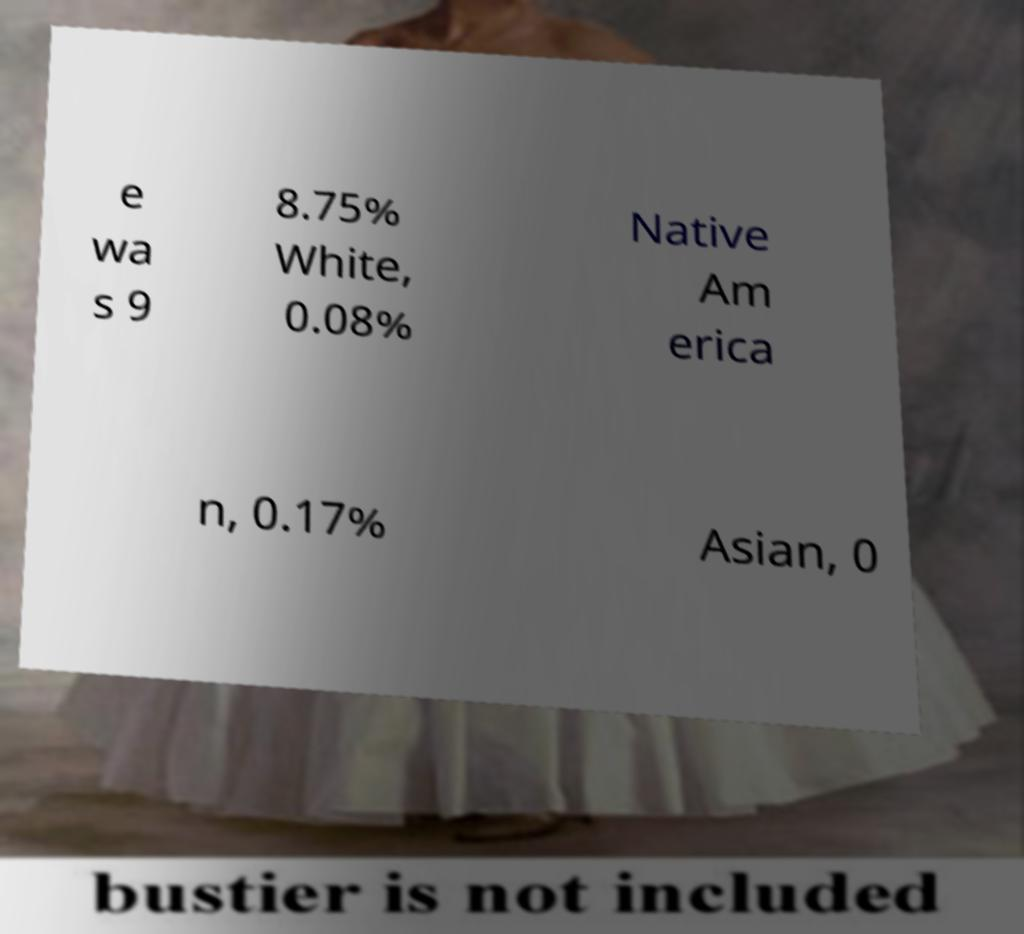There's text embedded in this image that I need extracted. Can you transcribe it verbatim? e wa s 9 8.75% White, 0.08% Native Am erica n, 0.17% Asian, 0 